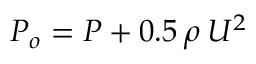Convert formula to latex. <formula><loc_0><loc_0><loc_500><loc_500>P _ { o } = P + 0 . 5 \, \rho \, U ^ { 2 }</formula> 